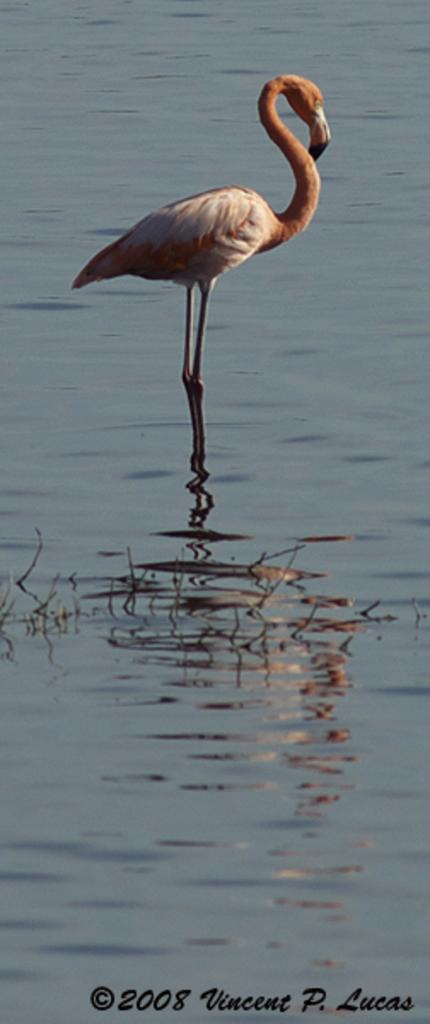What is the bird doing in the image? The bird is in the water. What else can be seen on the water in the image? There are objects on the water. Where is the text located in the image? The text is in the bottom left side of the picture. Can you see any dirt on the bird's foot in the image? There is no bird's foot visible in the image, as it only shows the bird in the water. 